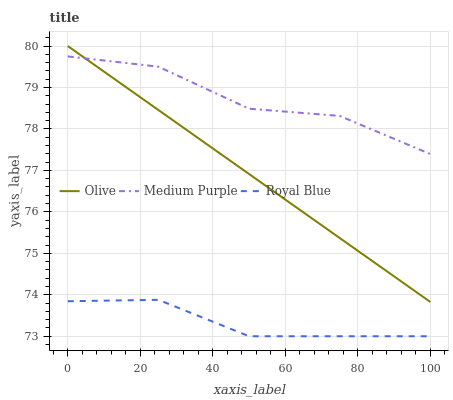Does Royal Blue have the minimum area under the curve?
Answer yes or no. Yes. Does Medium Purple have the maximum area under the curve?
Answer yes or no. Yes. Does Medium Purple have the minimum area under the curve?
Answer yes or no. No. Does Royal Blue have the maximum area under the curve?
Answer yes or no. No. Is Olive the smoothest?
Answer yes or no. Yes. Is Medium Purple the roughest?
Answer yes or no. Yes. Is Royal Blue the smoothest?
Answer yes or no. No. Is Royal Blue the roughest?
Answer yes or no. No. Does Royal Blue have the lowest value?
Answer yes or no. Yes. Does Medium Purple have the lowest value?
Answer yes or no. No. Does Olive have the highest value?
Answer yes or no. Yes. Does Medium Purple have the highest value?
Answer yes or no. No. Is Royal Blue less than Medium Purple?
Answer yes or no. Yes. Is Olive greater than Royal Blue?
Answer yes or no. Yes. Does Medium Purple intersect Olive?
Answer yes or no. Yes. Is Medium Purple less than Olive?
Answer yes or no. No. Is Medium Purple greater than Olive?
Answer yes or no. No. Does Royal Blue intersect Medium Purple?
Answer yes or no. No. 